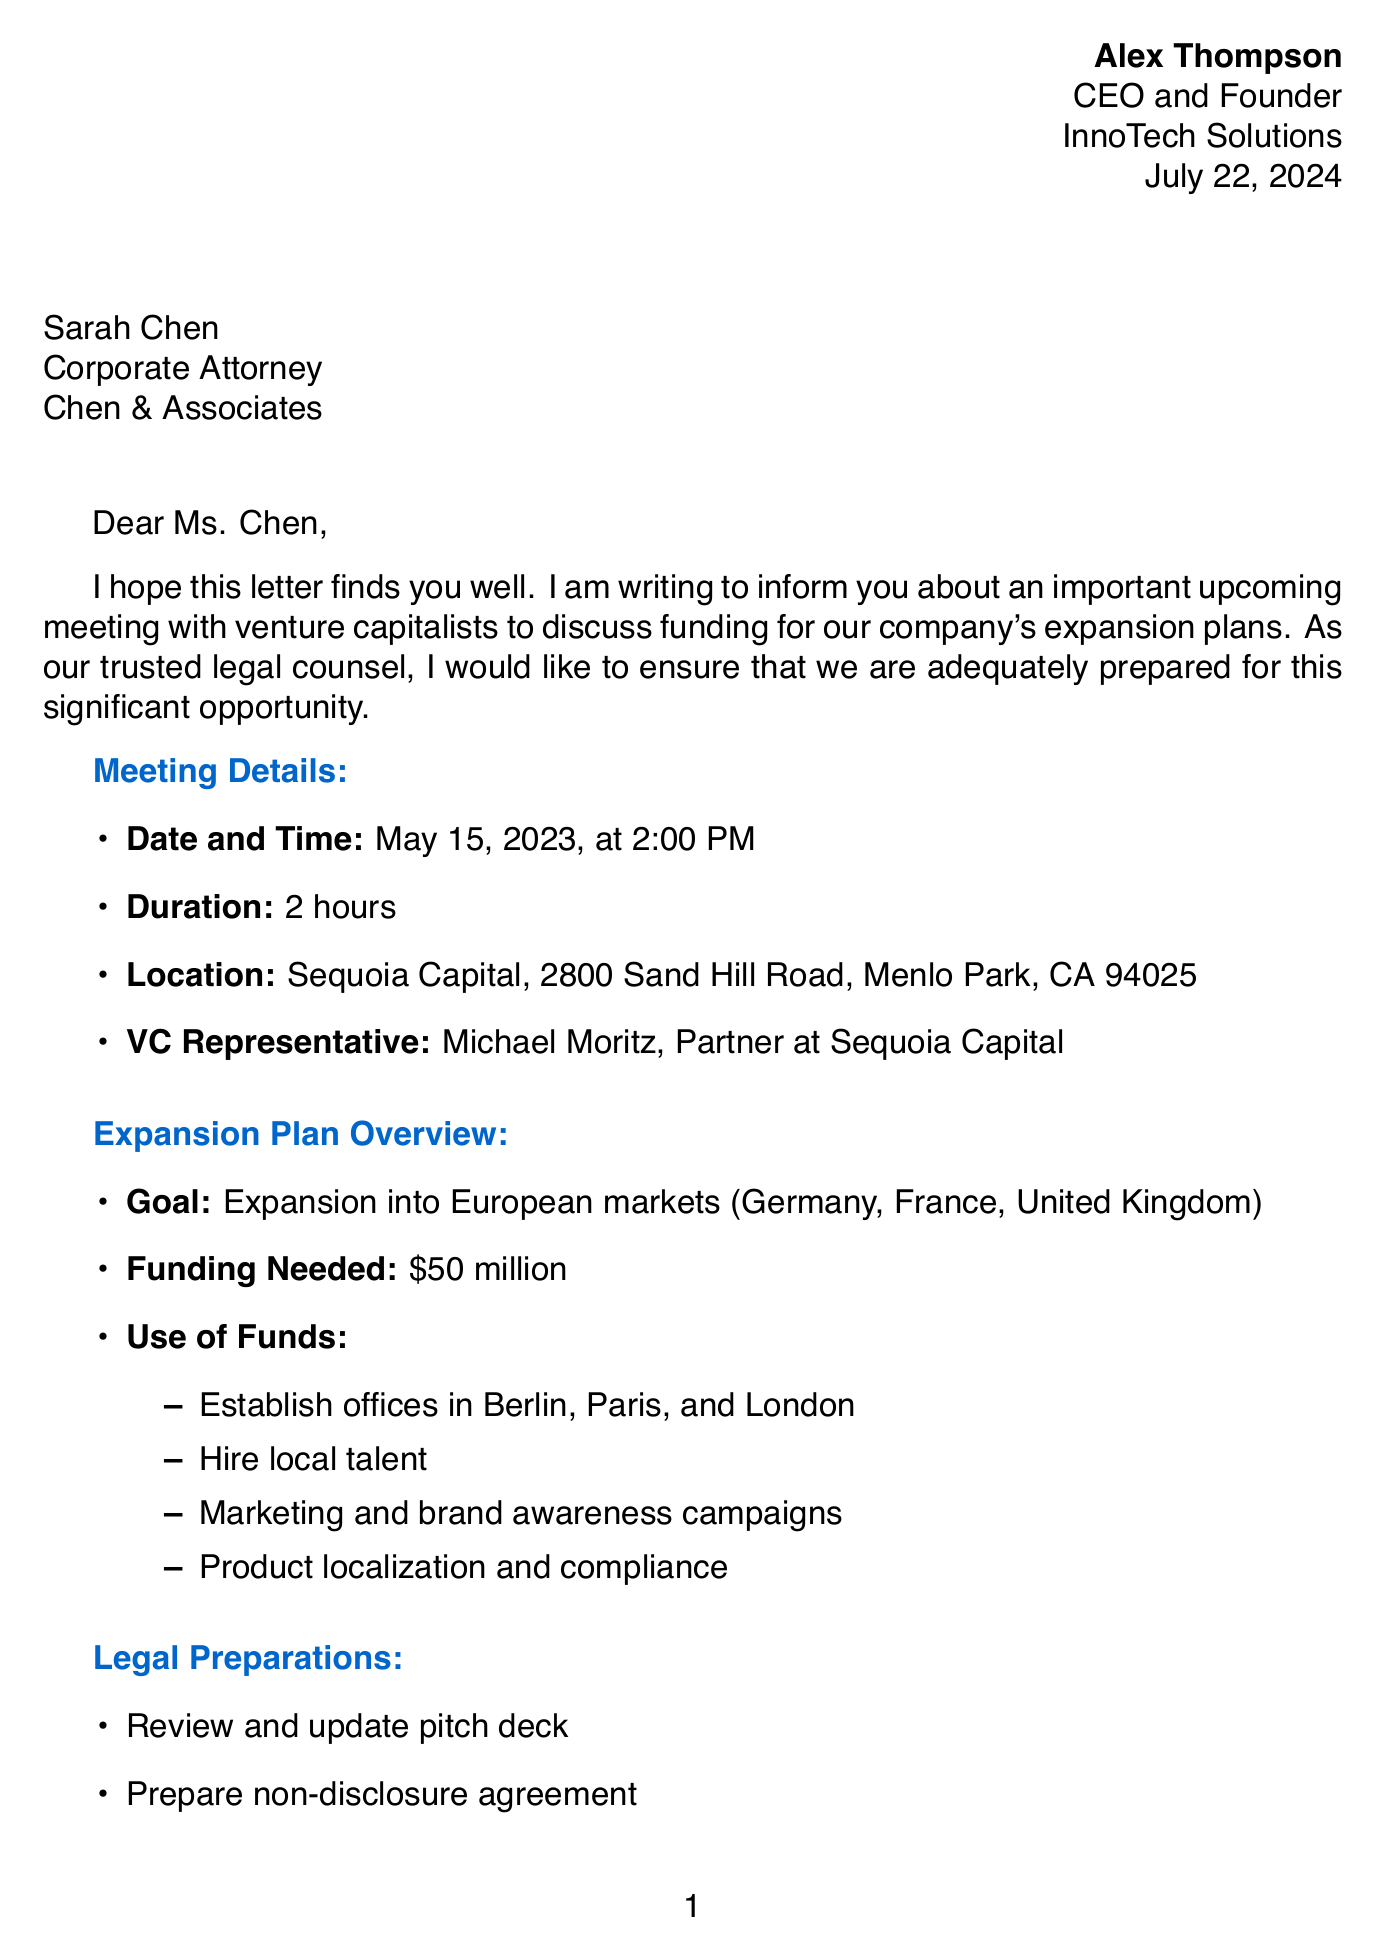What is the name of the sender? The sender's name is Alex Thompson, as stated at the beginning of the letter.
Answer: Alex Thompson What is the date of the meeting? The meeting date is clearly specified under the meeting details section.
Answer: May 15, 2023 How long is the meeting scheduled to last? The letter mentions the duration of the meeting in the meeting details.
Answer: 2 hours What is the funding needed for the expansion? The letter specifies the amount of funding needed for the expansion plan.
Answer: $50 million Which countries are targeted for expansion? The target countries for expansion are listed in the expansion plan overview.
Answer: Germany, France, United Kingdom What is the goal stated in the expansion plan? The goal for the expansion is explicitly mentioned in the document.
Answer: Expansion into European markets What type of legal documents are requested? The letter lists several types of documents that are requested.
Answer: Term sheet template What is a post-meeting action mentioned in the letter? The letter outlines specific actions to take after the meeting.
Answer: Schedule follow-up call with Sarah Chen What is the name of the VC firm mentioned? The name of the venture capital firm is mentioned in the meeting details.
Answer: Sequoia Capital 